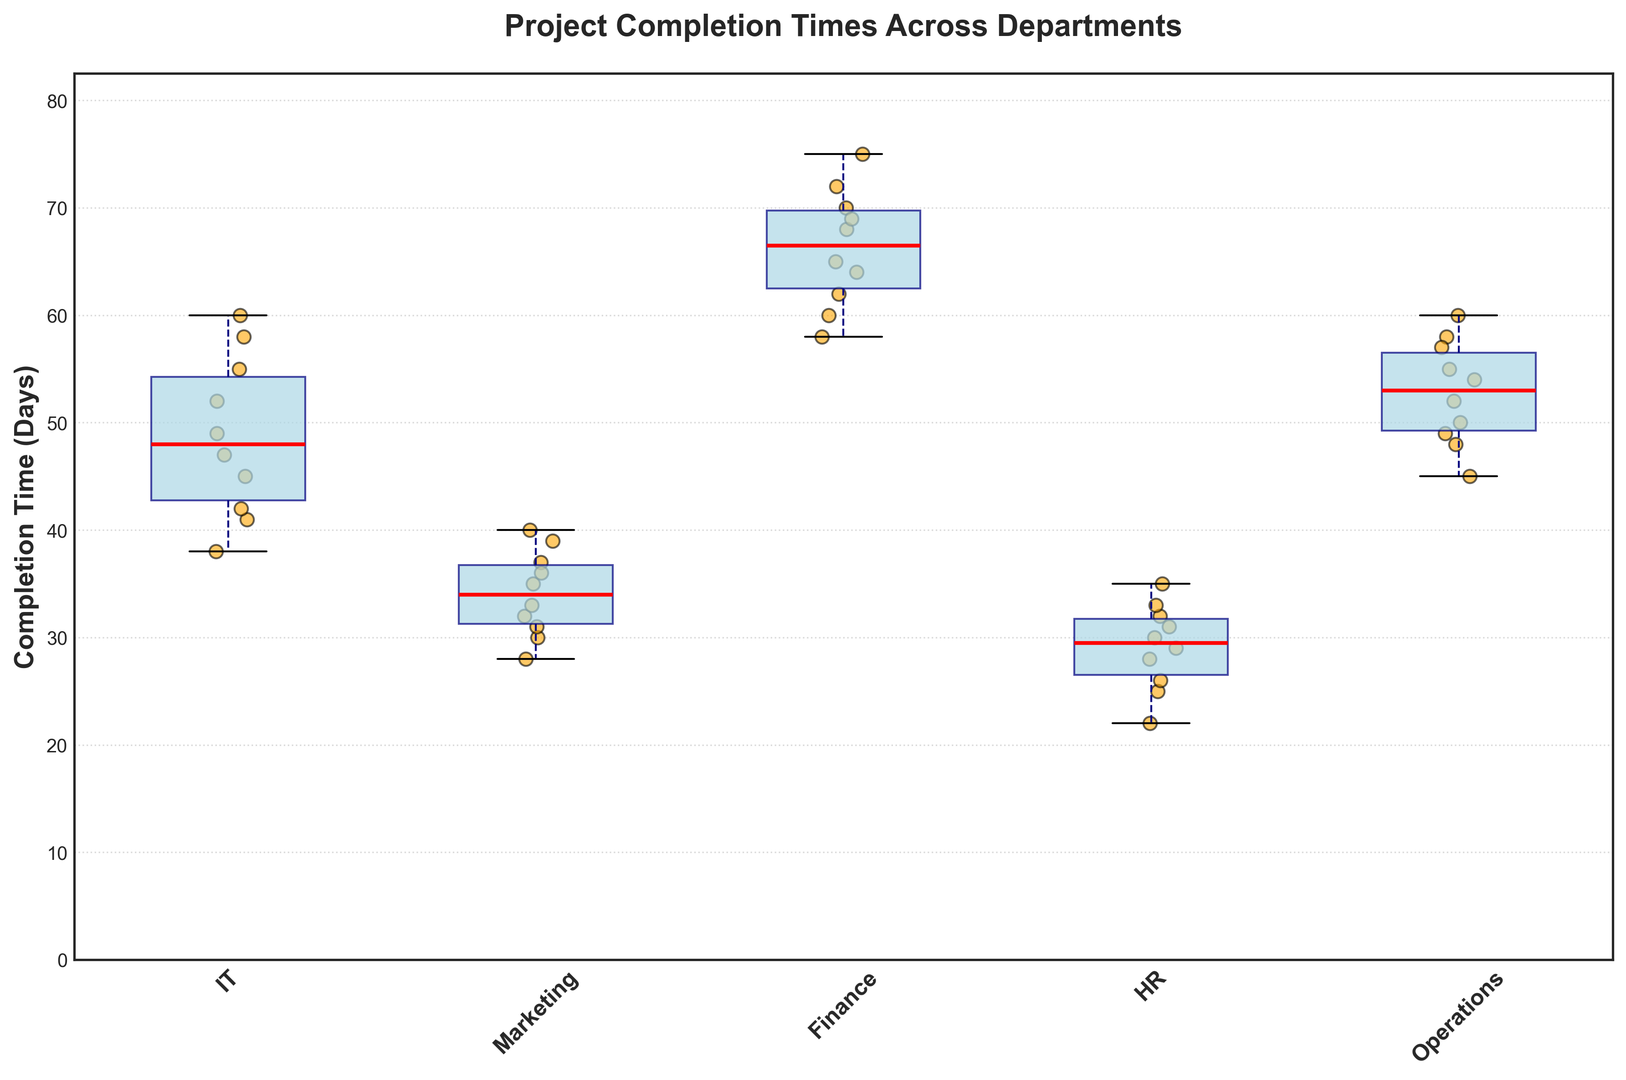What's the median project completion time for the IT department? To find the median project completion time for the IT department, locate the central value of the box for IT in the box plot. The median is marked by a red line inside the box.
Answer: 47 Which department has the highest median project completion time? To determine the department with the highest median project completion time, look for the highest red line inside the boxes.
Answer: Finance How does the range of project completion times for Marketing compare to that of IT? To compare the range for Marketing and IT, look at the vertical span between the top whisker (maximum) and the bottom whisker (minimum) for both departments.
Answer: IT has a larger range than Marketing Which department has the smallest interquartile range (IQR)? The IQR is represented by the height of the box. Identify the box with the smallest height.
Answer: HR Are there any outliers in the HR department? Outliers are typically indicated by individual points outside the whiskers of the box. Check if there are any isolated dots in the HR department's box plot.
Answer: No Which department shows the most consistency in project completion times? Consistency can be inferred by the smallest spread (range) of the whiskers and the box. Identify the department with the narrowest range and box.
Answer: HR Which department has the widest spread between the minimum and maximum project completion times? To find the widest spread, look at the department with the longest distance between the lower whisker (minimum) and upper whisker (maximum).
Answer: Finance What can be inferred about the completion times in the Operations department? Look at the position of the box, the length of the whiskers, and the position of the median line for Operations.
Answer: Operations completion times are quite consistent with a median around 54 days and moderate spread Compare the median completion time of Operations to that of Marketing. Locate the median red lines for both Operations and Marketing and note their positions relative to one another.
Answer: Operations median is higher than Marketing 